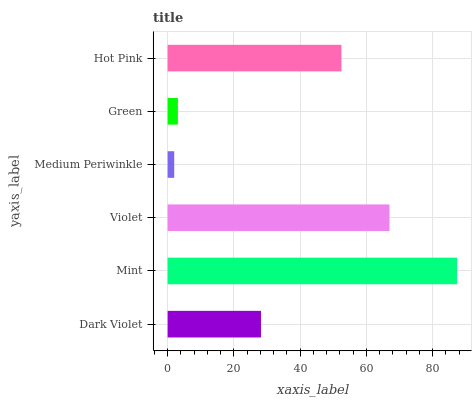Is Medium Periwinkle the minimum?
Answer yes or no. Yes. Is Mint the maximum?
Answer yes or no. Yes. Is Violet the minimum?
Answer yes or no. No. Is Violet the maximum?
Answer yes or no. No. Is Mint greater than Violet?
Answer yes or no. Yes. Is Violet less than Mint?
Answer yes or no. Yes. Is Violet greater than Mint?
Answer yes or no. No. Is Mint less than Violet?
Answer yes or no. No. Is Hot Pink the high median?
Answer yes or no. Yes. Is Dark Violet the low median?
Answer yes or no. Yes. Is Green the high median?
Answer yes or no. No. Is Green the low median?
Answer yes or no. No. 